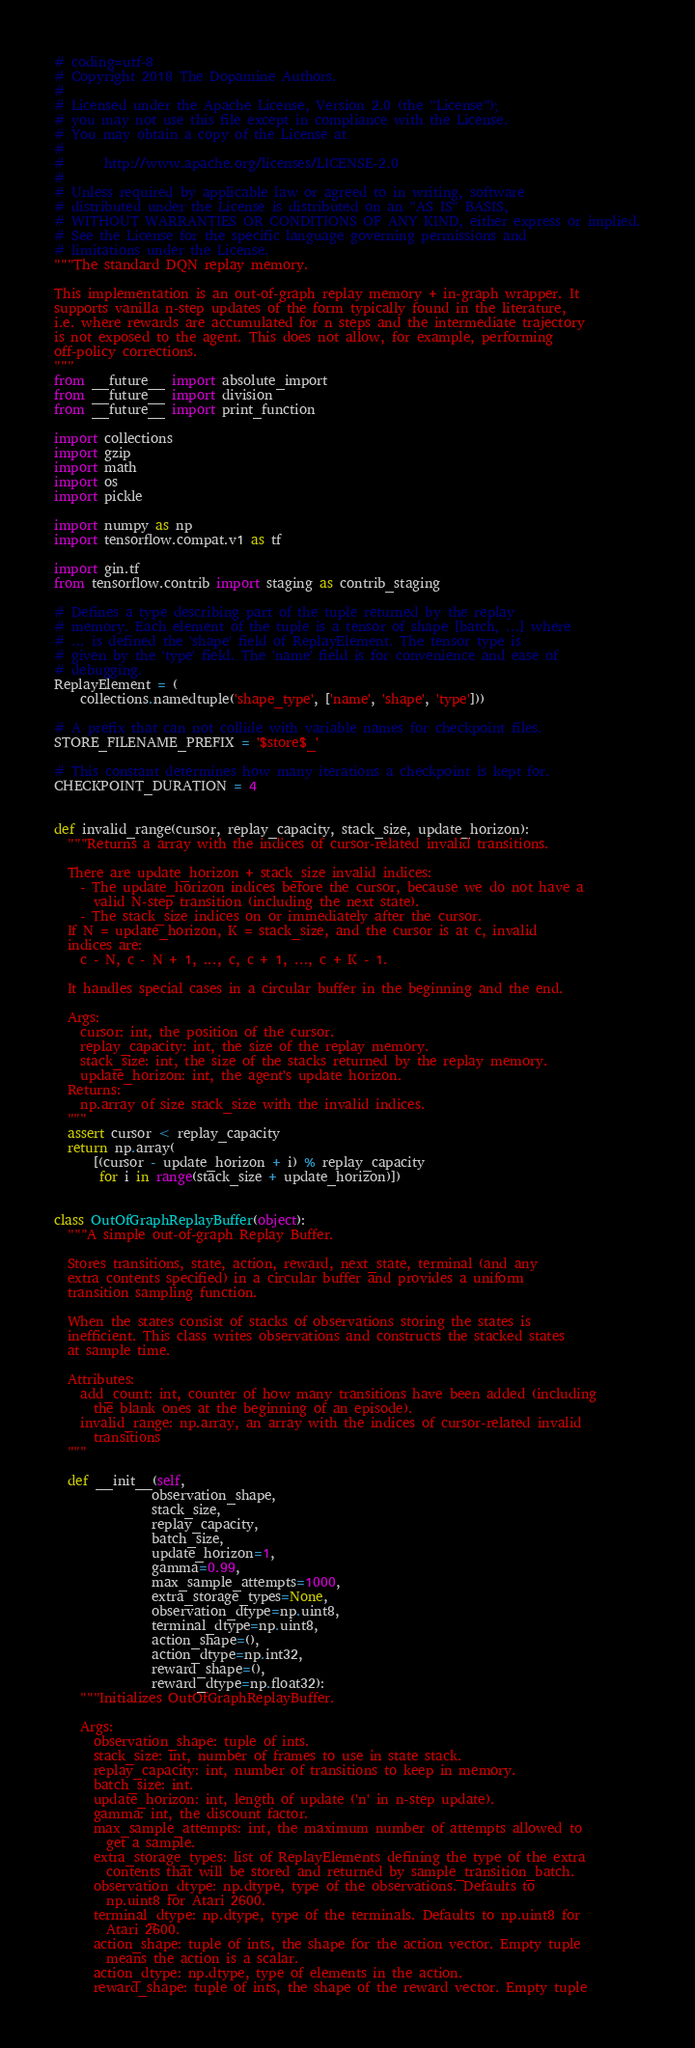Convert code to text. <code><loc_0><loc_0><loc_500><loc_500><_Python_># coding=utf-8
# Copyright 2018 The Dopamine Authors.
#
# Licensed under the Apache License, Version 2.0 (the "License");
# you may not use this file except in compliance with the License.
# You may obtain a copy of the License at
#
#      http://www.apache.org/licenses/LICENSE-2.0
#
# Unless required by applicable law or agreed to in writing, software
# distributed under the License is distributed on an "AS IS" BASIS,
# WITHOUT WARRANTIES OR CONDITIONS OF ANY KIND, either express or implied.
# See the License for the specific language governing permissions and
# limitations under the License.
"""The standard DQN replay memory.

This implementation is an out-of-graph replay memory + in-graph wrapper. It
supports vanilla n-step updates of the form typically found in the literature,
i.e. where rewards are accumulated for n steps and the intermediate trajectory
is not exposed to the agent. This does not allow, for example, performing
off-policy corrections.
"""
from __future__ import absolute_import
from __future__ import division
from __future__ import print_function

import collections
import gzip
import math
import os
import pickle

import numpy as np
import tensorflow.compat.v1 as tf

import gin.tf
from tensorflow.contrib import staging as contrib_staging

# Defines a type describing part of the tuple returned by the replay
# memory. Each element of the tuple is a tensor of shape [batch, ...] where
# ... is defined the 'shape' field of ReplayElement. The tensor type is
# given by the 'type' field. The 'name' field is for convenience and ease of
# debugging.
ReplayElement = (
    collections.namedtuple('shape_type', ['name', 'shape', 'type']))

# A prefix that can not collide with variable names for checkpoint files.
STORE_FILENAME_PREFIX = '$store$_'

# This constant determines how many iterations a checkpoint is kept for.
CHECKPOINT_DURATION = 4


def invalid_range(cursor, replay_capacity, stack_size, update_horizon):
  """Returns a array with the indices of cursor-related invalid transitions.

  There are update_horizon + stack_size invalid indices:
    - The update_horizon indices before the cursor, because we do not have a
      valid N-step transition (including the next state).
    - The stack_size indices on or immediately after the cursor.
  If N = update_horizon, K = stack_size, and the cursor is at c, invalid
  indices are:
    c - N, c - N + 1, ..., c, c + 1, ..., c + K - 1.

  It handles special cases in a circular buffer in the beginning and the end.

  Args:
    cursor: int, the position of the cursor.
    replay_capacity: int, the size of the replay memory.
    stack_size: int, the size of the stacks returned by the replay memory.
    update_horizon: int, the agent's update horizon.
  Returns:
    np.array of size stack_size with the invalid indices.
  """
  assert cursor < replay_capacity
  return np.array(
      [(cursor - update_horizon + i) % replay_capacity
       for i in range(stack_size + update_horizon)])


class OutOfGraphReplayBuffer(object):
  """A simple out-of-graph Replay Buffer.

  Stores transitions, state, action, reward, next_state, terminal (and any
  extra contents specified) in a circular buffer and provides a uniform
  transition sampling function.

  When the states consist of stacks of observations storing the states is
  inefficient. This class writes observations and constructs the stacked states
  at sample time.

  Attributes:
    add_count: int, counter of how many transitions have been added (including
      the blank ones at the beginning of an episode).
    invalid_range: np.array, an array with the indices of cursor-related invalid
      transitions
  """

  def __init__(self,
               observation_shape,
               stack_size,
               replay_capacity,
               batch_size,
               update_horizon=1,
               gamma=0.99,
               max_sample_attempts=1000,
               extra_storage_types=None,
               observation_dtype=np.uint8,
               terminal_dtype=np.uint8,
               action_shape=(),
               action_dtype=np.int32,
               reward_shape=(),
               reward_dtype=np.float32):
    """Initializes OutOfGraphReplayBuffer.

    Args:
      observation_shape: tuple of ints.
      stack_size: int, number of frames to use in state stack.
      replay_capacity: int, number of transitions to keep in memory.
      batch_size: int.
      update_horizon: int, length of update ('n' in n-step update).
      gamma: int, the discount factor.
      max_sample_attempts: int, the maximum number of attempts allowed to
        get a sample.
      extra_storage_types: list of ReplayElements defining the type of the extra
        contents that will be stored and returned by sample_transition_batch.
      observation_dtype: np.dtype, type of the observations. Defaults to
        np.uint8 for Atari 2600.
      terminal_dtype: np.dtype, type of the terminals. Defaults to np.uint8 for
        Atari 2600.
      action_shape: tuple of ints, the shape for the action vector. Empty tuple
        means the action is a scalar.
      action_dtype: np.dtype, type of elements in the action.
      reward_shape: tuple of ints, the shape of the reward vector. Empty tuple</code> 